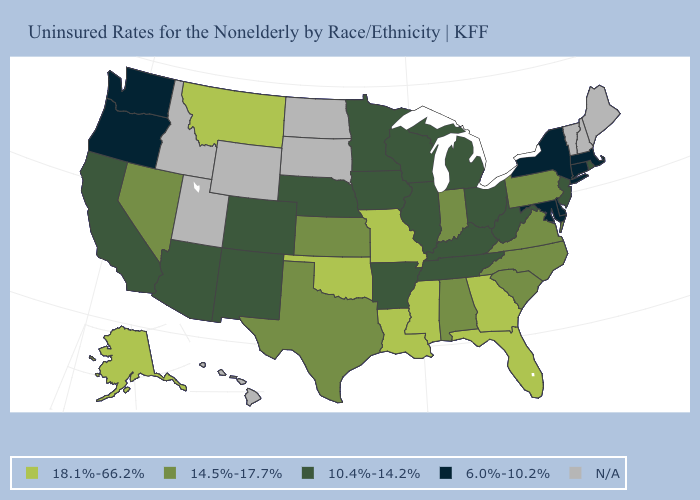Name the states that have a value in the range 10.4%-14.2%?
Concise answer only. Arizona, Arkansas, California, Colorado, Illinois, Iowa, Kentucky, Michigan, Minnesota, Nebraska, New Jersey, New Mexico, Ohio, Rhode Island, Tennessee, West Virginia, Wisconsin. What is the highest value in the MidWest ?
Concise answer only. 18.1%-66.2%. What is the highest value in the West ?
Give a very brief answer. 18.1%-66.2%. Is the legend a continuous bar?
Concise answer only. No. Which states hav the highest value in the Northeast?
Concise answer only. Pennsylvania. Among the states that border West Virginia , which have the lowest value?
Quick response, please. Maryland. What is the highest value in states that border West Virginia?
Quick response, please. 14.5%-17.7%. Which states have the lowest value in the USA?
Quick response, please. Connecticut, Delaware, Maryland, Massachusetts, New York, Oregon, Washington. What is the lowest value in the USA?
Quick response, please. 6.0%-10.2%. Does the first symbol in the legend represent the smallest category?
Give a very brief answer. No. Which states hav the highest value in the Northeast?
Keep it brief. Pennsylvania. Which states have the lowest value in the USA?
Concise answer only. Connecticut, Delaware, Maryland, Massachusetts, New York, Oregon, Washington. Name the states that have a value in the range 6.0%-10.2%?
Be succinct. Connecticut, Delaware, Maryland, Massachusetts, New York, Oregon, Washington. Name the states that have a value in the range 6.0%-10.2%?
Quick response, please. Connecticut, Delaware, Maryland, Massachusetts, New York, Oregon, Washington. 